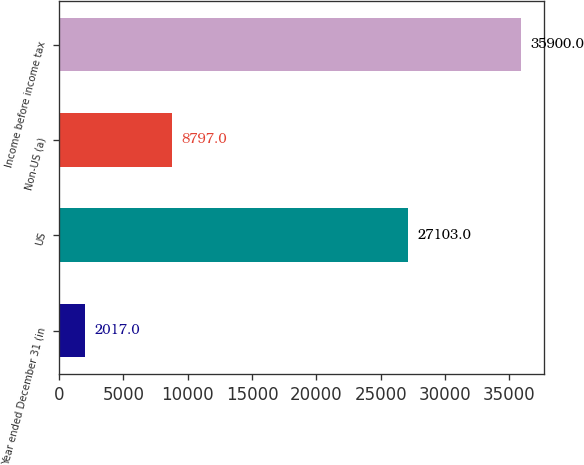<chart> <loc_0><loc_0><loc_500><loc_500><bar_chart><fcel>Year ended December 31 (in<fcel>US<fcel>Non-US (a)<fcel>Income before income tax<nl><fcel>2017<fcel>27103<fcel>8797<fcel>35900<nl></chart> 